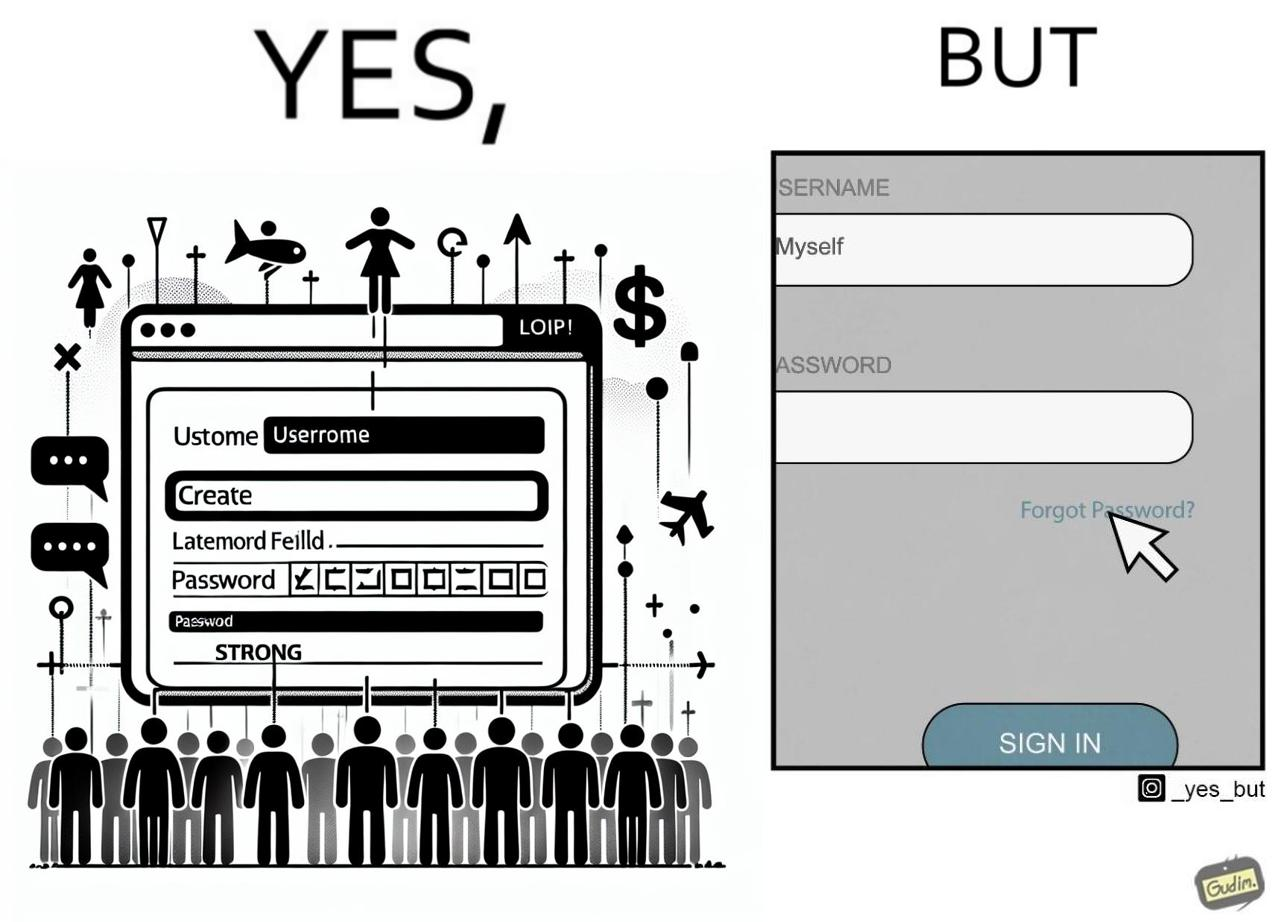What does this image depict? The image is ironic, because people set such a strong passwords for their accounts that they even forget the password and need to reset them 